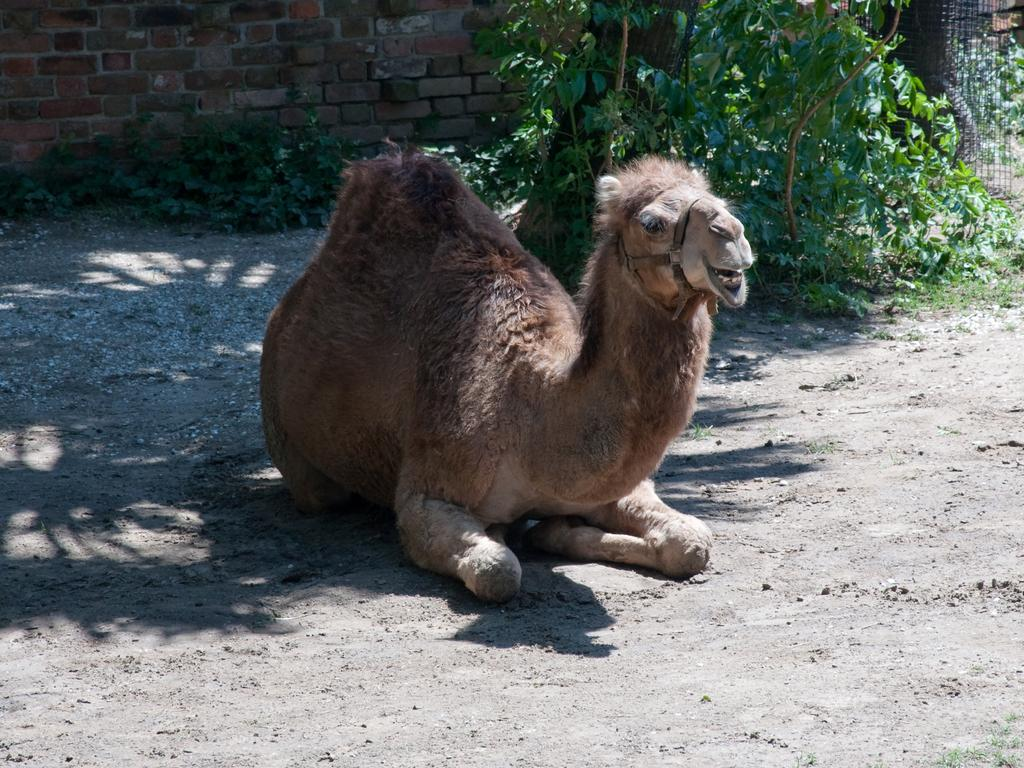What animal is on the ground in the image? There is a camel on the ground in the image. What type of vegetation can be seen in the image? There are plants in the image. What can be seen in the background of the image? There is a wall visible in the background. What is the taste of the education being offered in the image? There is no education present in the image, so it is not possible to determine its taste. 